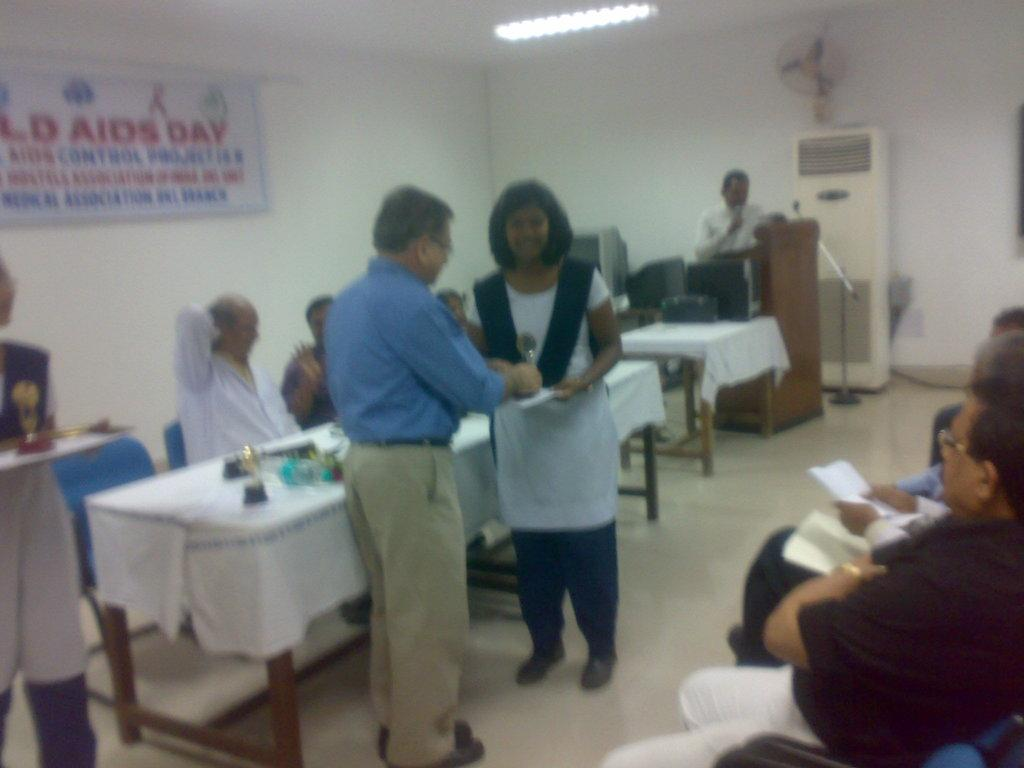What is the setting of the image? The image takes place in a room. What activity is happening in the room? There are people conducting a medical camp in the room. Are there any people sitting or standing in the room? Yes, some people are sitting and some are standing in the room. What is the price of the carriage in the room? There is no carriage present in the room, so it is not possible to determine its price. 